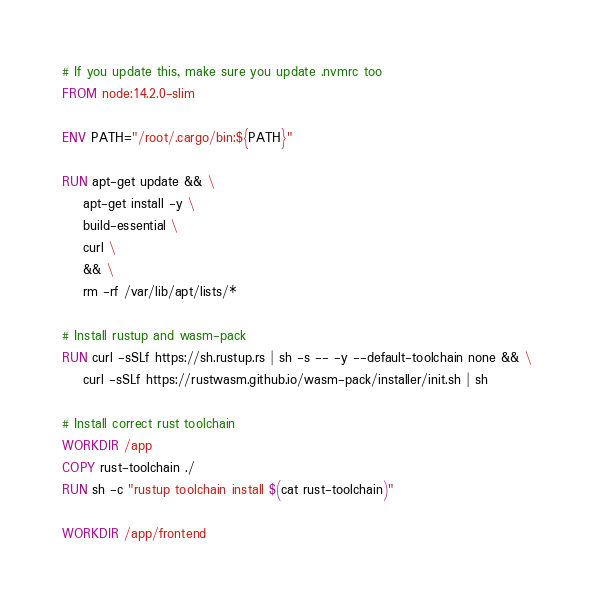<code> <loc_0><loc_0><loc_500><loc_500><_Dockerfile_># If you update this, make sure you update .nvmrc too
FROM node:14.2.0-slim

ENV PATH="/root/.cargo/bin:${PATH}"

RUN apt-get update && \
    apt-get install -y \
    build-essential \
    curl \
    && \
    rm -rf /var/lib/apt/lists/*

# Install rustup and wasm-pack
RUN curl -sSLf https://sh.rustup.rs | sh -s -- -y --default-toolchain none && \
    curl -sSLf https://rustwasm.github.io/wasm-pack/installer/init.sh | sh

# Install correct rust toolchain
WORKDIR /app
COPY rust-toolchain ./
RUN sh -c "rustup toolchain install $(cat rust-toolchain)"

WORKDIR /app/frontend
</code> 